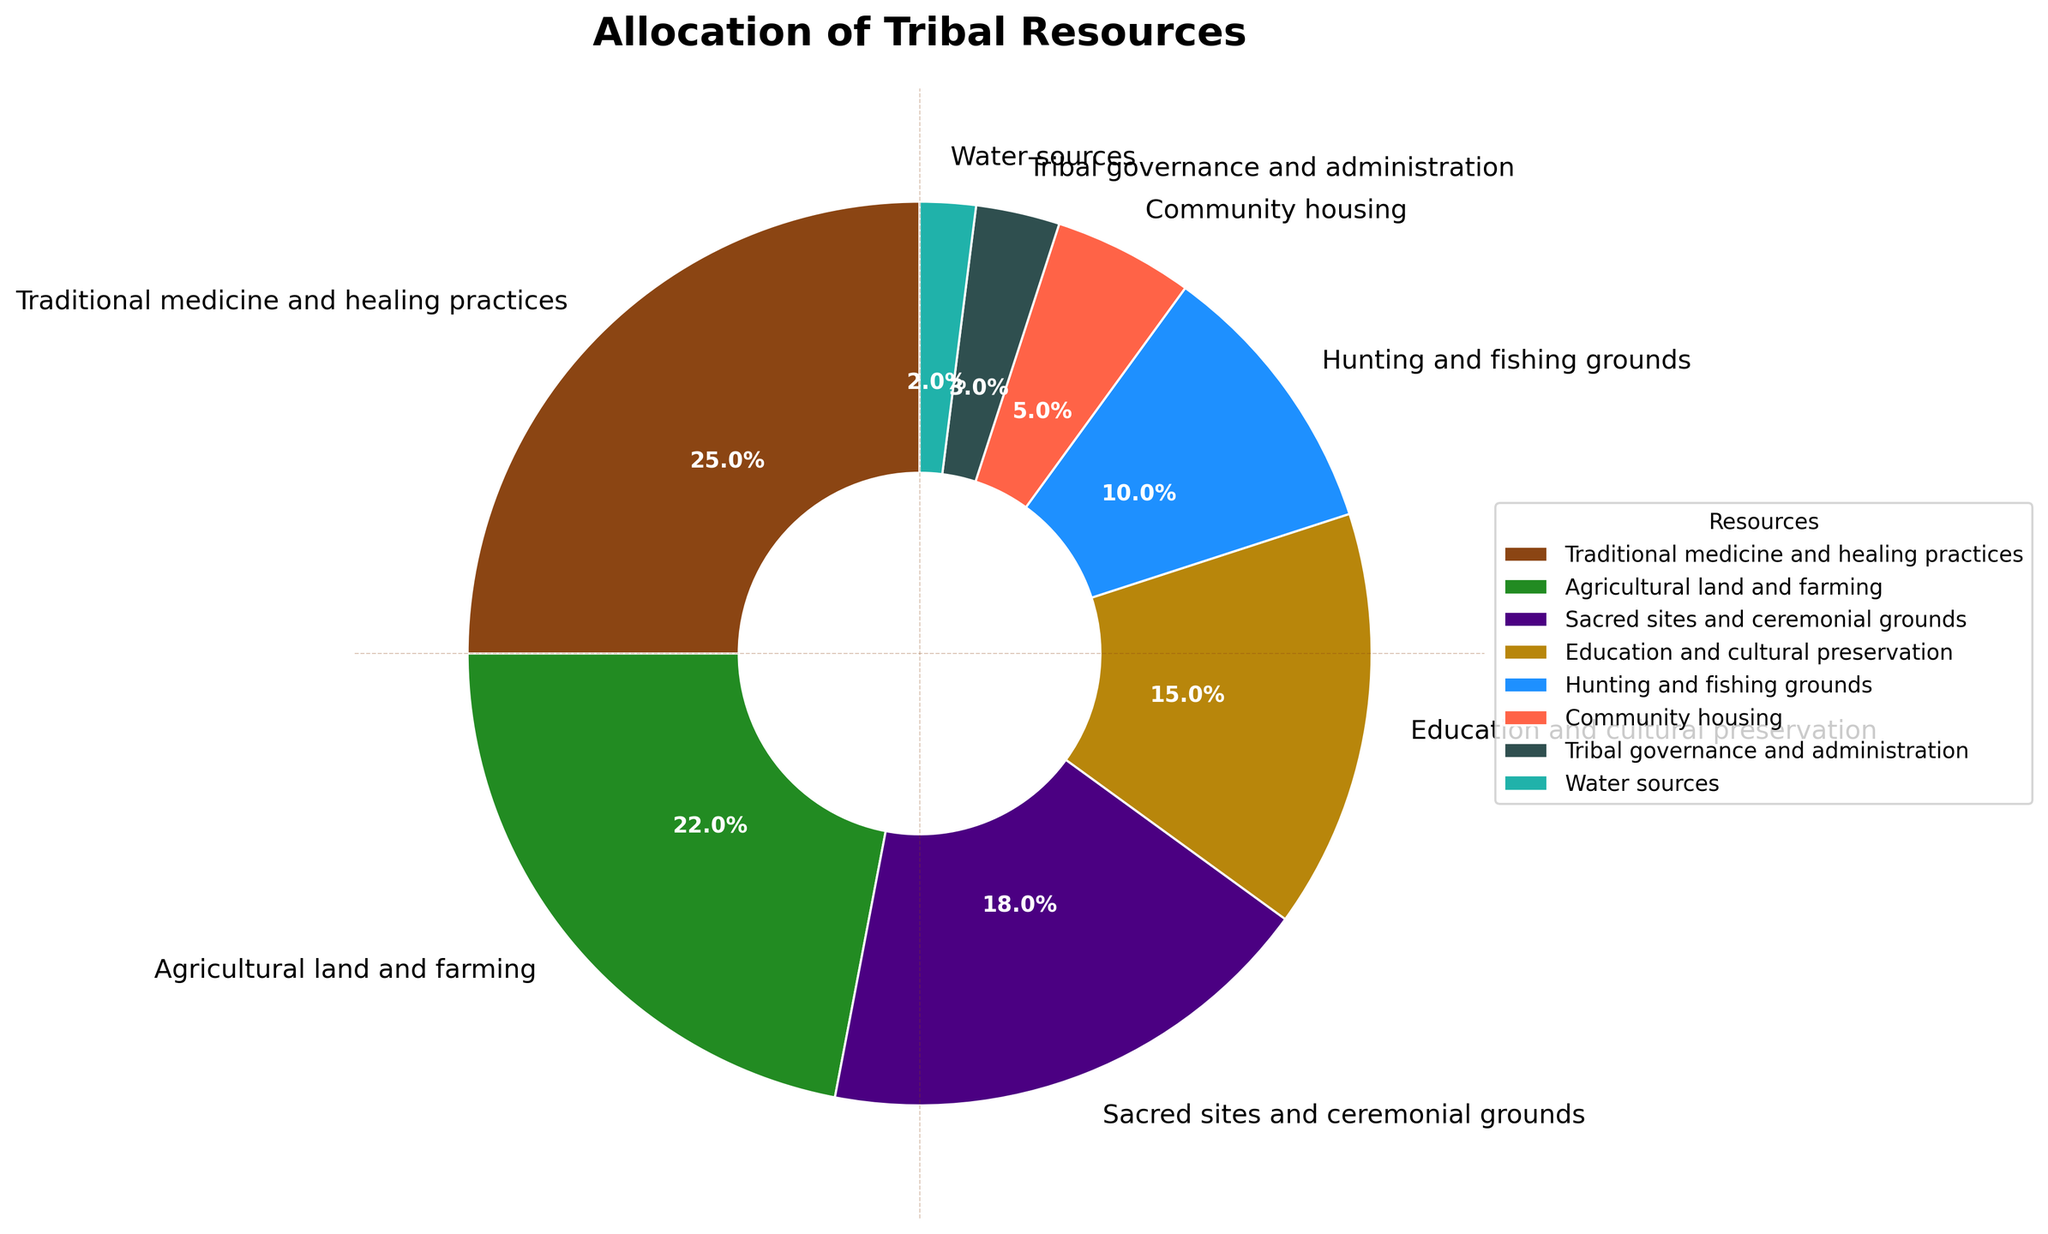What's the largest allocation of resources? The largest portion of the pie chart is assigned to Traditional medicine and healing practices, which occupies the biggest wedge of the chart.
Answer: Traditional medicine and healing practices How do the resources allocated to Agricultural land and farming compare to Sacred sites and ceremonial grounds? Comparing the respective percentages in the chart, Agricultural land and farming is 22%, which is slightly more than Sacred sites and ceremonial grounds at 18%.
Answer: Agricultural land and farming has more What is the combined allocation percentage for Education and cultural preservation and Community housing? Adding the percentages for these two categories: 15% (Education and cultural preservation) + 5% (Community housing) = 20%.
Answer: 20% Which resource has the smallest allocation in the pie chart? The smallest wedge in the pie chart is dedicated to Water sources, which has an allocation of 2%.
Answer: Water sources How much more is allocated to Hunting and fishing grounds compared to Tribal governance and administration? Hunting and fishing grounds have 10% allocation, while Tribal governance and administration have 3%. The difference is 10% - 3% = 7%.
Answer: 7% Are there more resources allocated to Sacred sites and ceremonial grounds or Water sources? By how much? Sacred sites and ceremonial grounds have an allocation of 18%, while Water sources have 2%. The difference is 18% - 2% = 16%.
Answer: Sacred sites and ceremonial grounds by 16% Which three resources together cover more than 60% of the total allocation? Adding the allocations of the three largest categories: Traditional medicine and healing practices (25%), Agricultural land and farming (22%), and Sacred sites and ceremonial grounds (18%) gives 25% + 22% + 18% = 65%.
Answer: Traditional medicine and healing practices, Agricultural land and farming, Sacred sites and ceremonial grounds What is the percentage difference between the highest and lowest allocated resources? The highest allocated resource is Traditional medicine and healing practices at 25%, and the lowest is Water sources at 2%. The difference is 25% - 2% = 23%.
Answer: 23% Which resource has an allocation percentage that is closest to the median allocation value? Listing the percentages in order (2, 3, 5, 10, 15, 18, 22, 25), the middle values are 10 and 15. The median is (10 + 15)/2 = 12.5, and the closest to this median is Hunting and fishing grounds at 10%.
Answer: Hunting and fishing grounds 